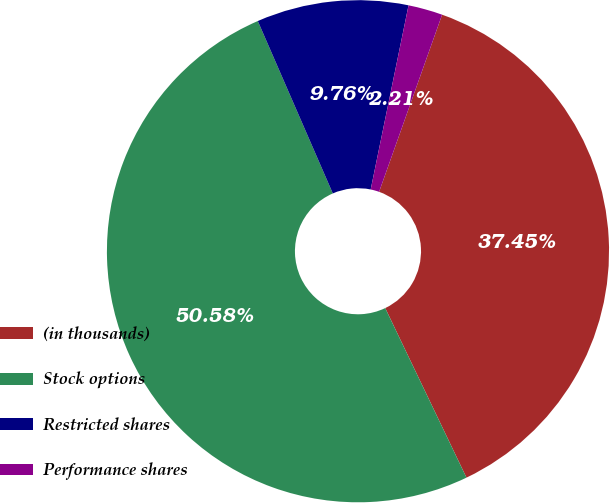<chart> <loc_0><loc_0><loc_500><loc_500><pie_chart><fcel>(in thousands)<fcel>Stock options<fcel>Restricted shares<fcel>Performance shares<nl><fcel>37.45%<fcel>50.58%<fcel>9.76%<fcel>2.21%<nl></chart> 